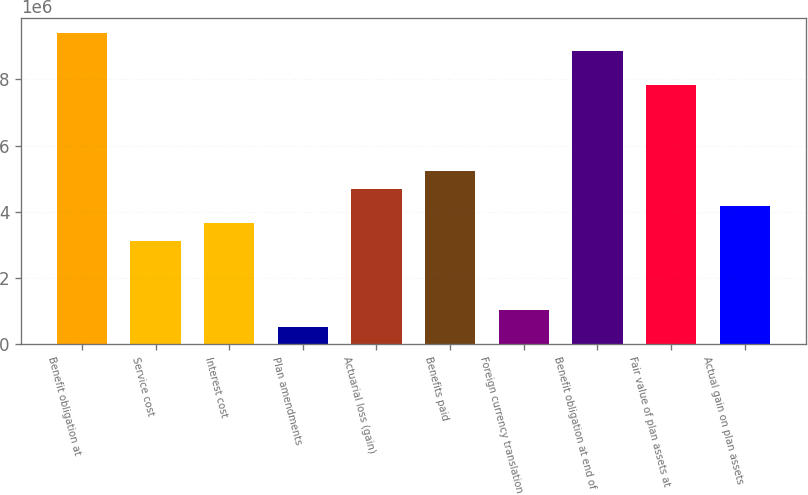Convert chart. <chart><loc_0><loc_0><loc_500><loc_500><bar_chart><fcel>Benefit obligation at<fcel>Service cost<fcel>Interest cost<fcel>Plan amendments<fcel>Actuarial loss (gain)<fcel>Benefits paid<fcel>Foreign currency translation<fcel>Benefit obligation at end of<fcel>Fair value of plan assets at<fcel>Actual gain on plan assets<nl><fcel>9.39209e+06<fcel>3.13074e+06<fcel>3.65252e+06<fcel>521841<fcel>4.69608e+06<fcel>5.21786e+06<fcel>1.04362e+06<fcel>8.87031e+06<fcel>7.82676e+06<fcel>4.1743e+06<nl></chart> 